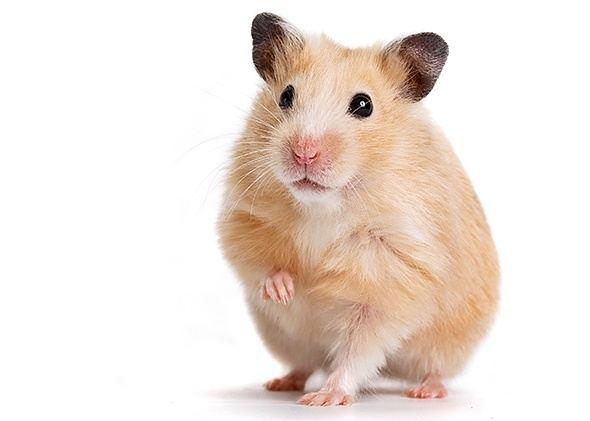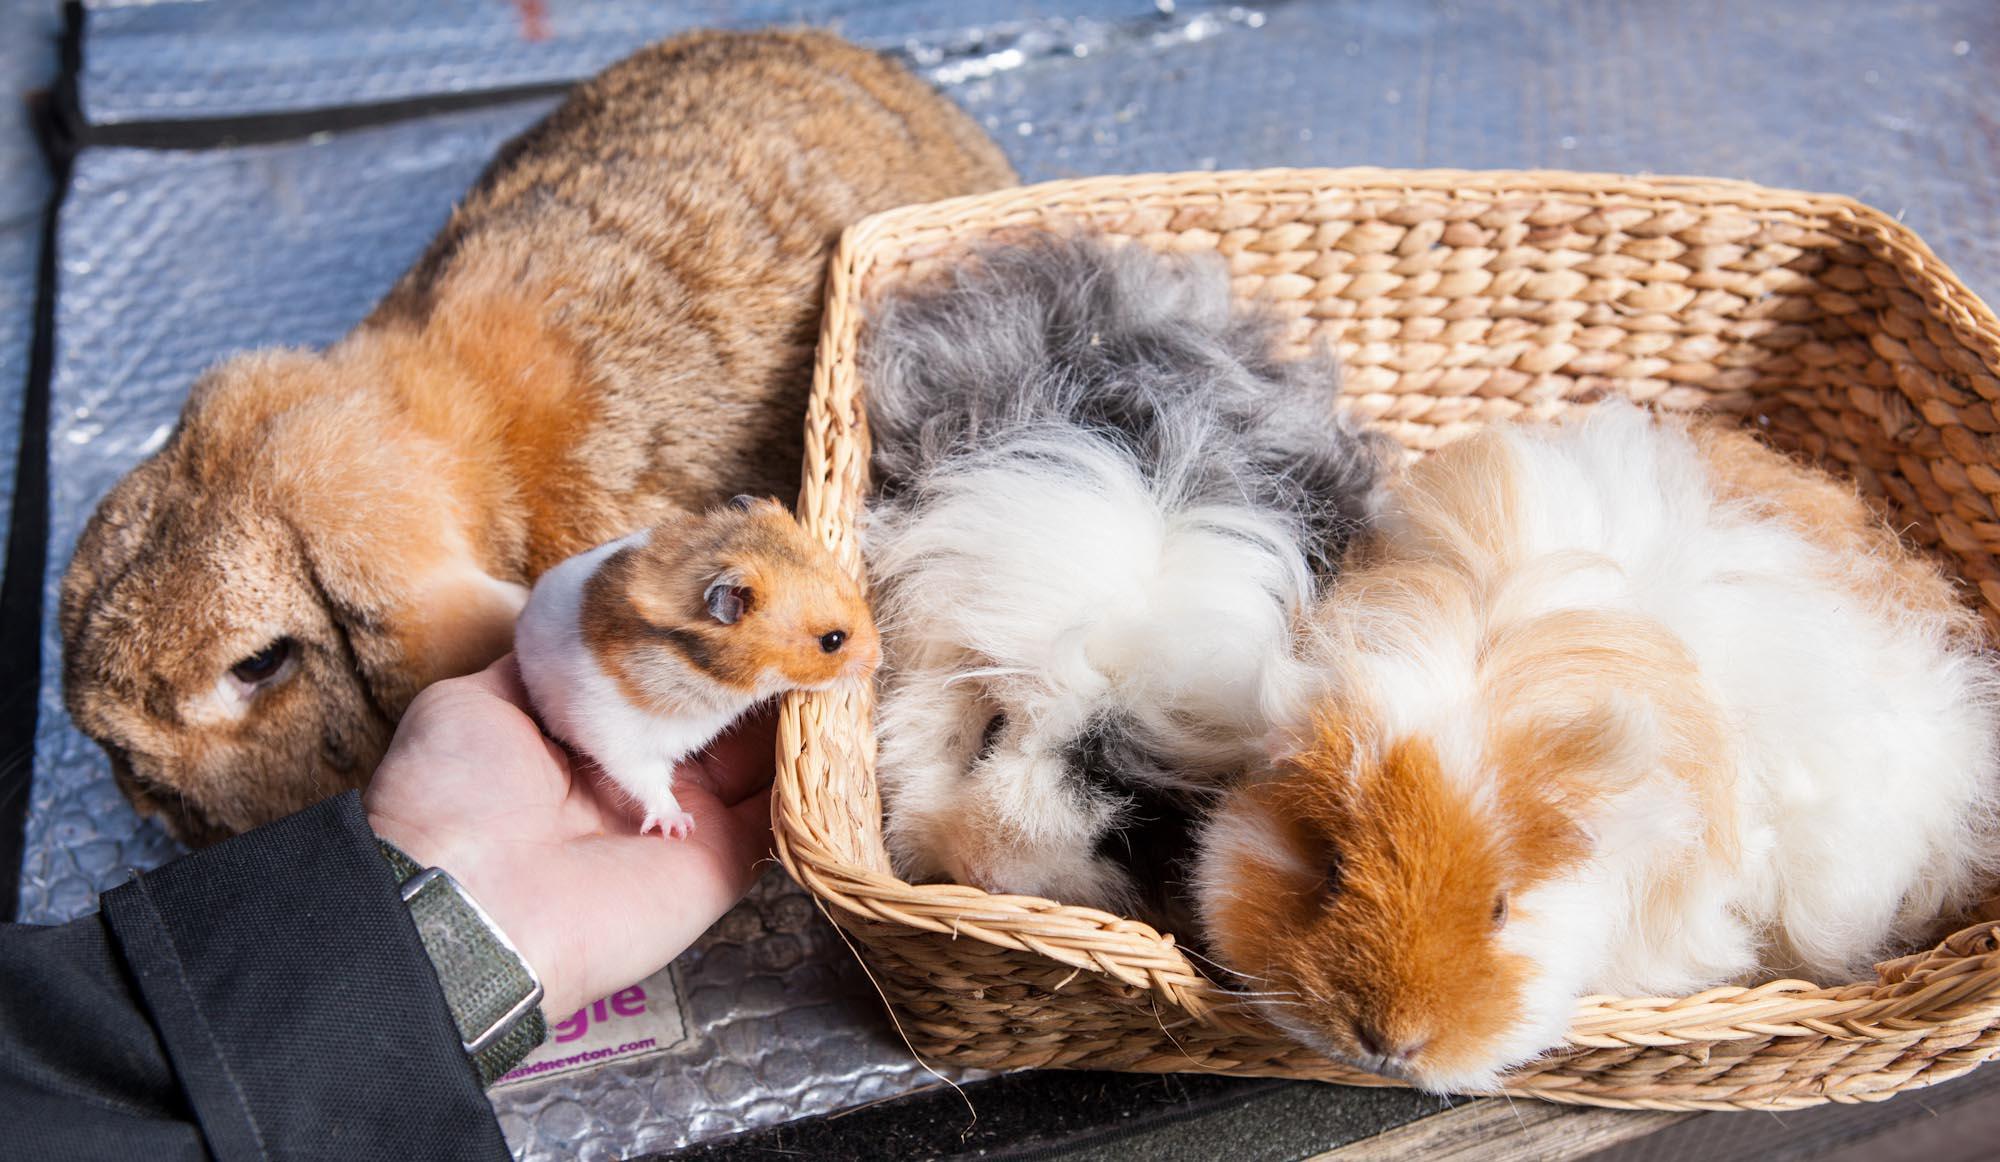The first image is the image on the left, the second image is the image on the right. Considering the images on both sides, is "The hamster in one of the images is in a wire cage." valid? Answer yes or no. No. 